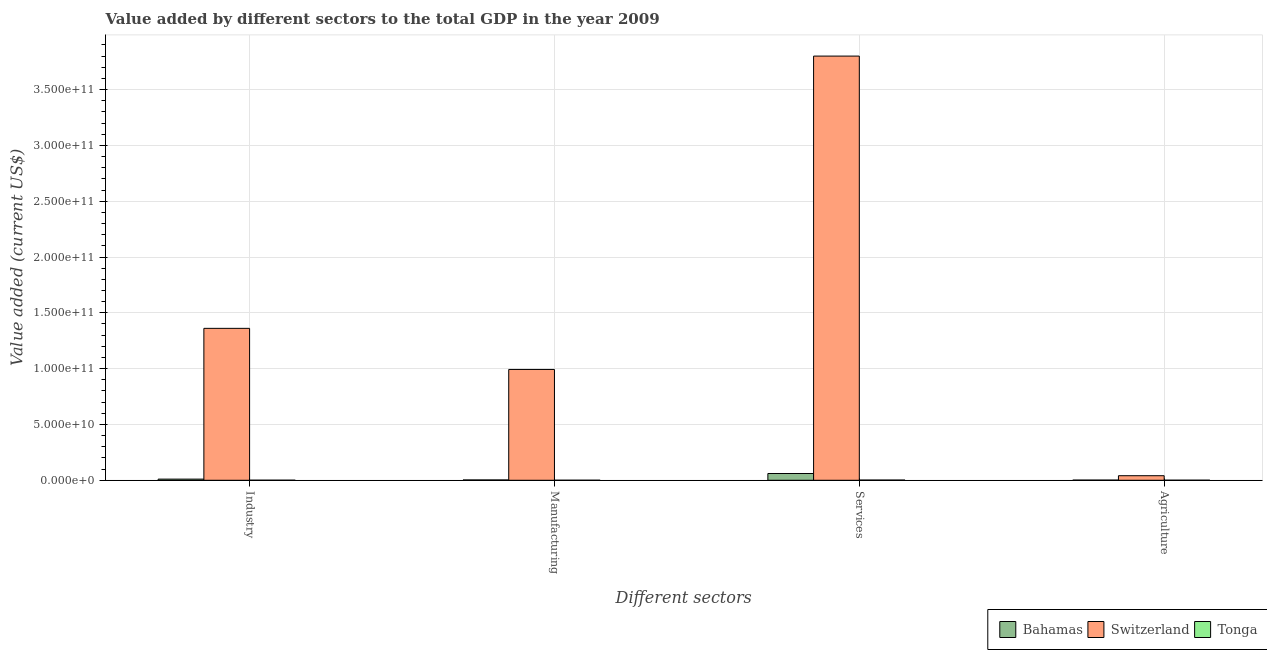How many different coloured bars are there?
Your answer should be very brief. 3. How many groups of bars are there?
Your answer should be compact. 4. Are the number of bars on each tick of the X-axis equal?
Your response must be concise. Yes. How many bars are there on the 3rd tick from the left?
Make the answer very short. 3. What is the label of the 4th group of bars from the left?
Offer a terse response. Agriculture. What is the value added by manufacturing sector in Bahamas?
Provide a succinct answer. 2.88e+08. Across all countries, what is the maximum value added by agricultural sector?
Your response must be concise. 4.08e+09. Across all countries, what is the minimum value added by manufacturing sector?
Your response must be concise. 2.13e+07. In which country was the value added by industrial sector maximum?
Ensure brevity in your answer.  Switzerland. In which country was the value added by agricultural sector minimum?
Your response must be concise. Tonga. What is the total value added by manufacturing sector in the graph?
Your answer should be very brief. 9.96e+1. What is the difference between the value added by agricultural sector in Tonga and that in Bahamas?
Your answer should be very brief. -9.88e+07. What is the difference between the value added by industrial sector in Switzerland and the value added by agricultural sector in Tonga?
Provide a succinct answer. 1.36e+11. What is the average value added by manufacturing sector per country?
Make the answer very short. 3.32e+1. What is the difference between the value added by manufacturing sector and value added by services sector in Switzerland?
Provide a short and direct response. -2.81e+11. In how many countries, is the value added by manufacturing sector greater than 350000000000 US$?
Your answer should be very brief. 0. What is the ratio of the value added by industrial sector in Bahamas to that in Tonga?
Offer a terse response. 19.07. Is the value added by industrial sector in Bahamas less than that in Tonga?
Provide a succinct answer. No. What is the difference between the highest and the second highest value added by agricultural sector?
Keep it short and to the point. 3.93e+09. What is the difference between the highest and the lowest value added by services sector?
Your answer should be very brief. 3.80e+11. Is the sum of the value added by agricultural sector in Bahamas and Tonga greater than the maximum value added by industrial sector across all countries?
Ensure brevity in your answer.  No. Is it the case that in every country, the sum of the value added by agricultural sector and value added by services sector is greater than the sum of value added by industrial sector and value added by manufacturing sector?
Give a very brief answer. No. What does the 1st bar from the left in Agriculture represents?
Ensure brevity in your answer.  Bahamas. What does the 3rd bar from the right in Industry represents?
Offer a terse response. Bahamas. Is it the case that in every country, the sum of the value added by industrial sector and value added by manufacturing sector is greater than the value added by services sector?
Ensure brevity in your answer.  No. How many countries are there in the graph?
Keep it short and to the point. 3. Are the values on the major ticks of Y-axis written in scientific E-notation?
Provide a succinct answer. Yes. Does the graph contain any zero values?
Your answer should be very brief. No. Where does the legend appear in the graph?
Your answer should be very brief. Bottom right. How many legend labels are there?
Provide a succinct answer. 3. How are the legend labels stacked?
Offer a terse response. Horizontal. What is the title of the graph?
Offer a terse response. Value added by different sectors to the total GDP in the year 2009. What is the label or title of the X-axis?
Ensure brevity in your answer.  Different sectors. What is the label or title of the Y-axis?
Your response must be concise. Value added (current US$). What is the Value added (current US$) of Bahamas in Industry?
Your response must be concise. 1.03e+09. What is the Value added (current US$) of Switzerland in Industry?
Keep it short and to the point. 1.36e+11. What is the Value added (current US$) in Tonga in Industry?
Your answer should be very brief. 5.43e+07. What is the Value added (current US$) in Bahamas in Manufacturing?
Your response must be concise. 2.88e+08. What is the Value added (current US$) in Switzerland in Manufacturing?
Offer a terse response. 9.93e+1. What is the Value added (current US$) of Tonga in Manufacturing?
Provide a succinct answer. 2.13e+07. What is the Value added (current US$) in Bahamas in Services?
Offer a terse response. 6.06e+09. What is the Value added (current US$) in Switzerland in Services?
Keep it short and to the point. 3.80e+11. What is the Value added (current US$) of Tonga in Services?
Your response must be concise. 1.75e+08. What is the Value added (current US$) of Bahamas in Agriculture?
Offer a terse response. 1.49e+08. What is the Value added (current US$) in Switzerland in Agriculture?
Give a very brief answer. 4.08e+09. What is the Value added (current US$) in Tonga in Agriculture?
Offer a terse response. 5.00e+07. Across all Different sectors, what is the maximum Value added (current US$) of Bahamas?
Provide a succinct answer. 6.06e+09. Across all Different sectors, what is the maximum Value added (current US$) in Switzerland?
Provide a short and direct response. 3.80e+11. Across all Different sectors, what is the maximum Value added (current US$) of Tonga?
Your answer should be very brief. 1.75e+08. Across all Different sectors, what is the minimum Value added (current US$) in Bahamas?
Make the answer very short. 1.49e+08. Across all Different sectors, what is the minimum Value added (current US$) of Switzerland?
Ensure brevity in your answer.  4.08e+09. Across all Different sectors, what is the minimum Value added (current US$) in Tonga?
Provide a succinct answer. 2.13e+07. What is the total Value added (current US$) of Bahamas in the graph?
Keep it short and to the point. 7.53e+09. What is the total Value added (current US$) of Switzerland in the graph?
Your response must be concise. 6.19e+11. What is the total Value added (current US$) in Tonga in the graph?
Provide a succinct answer. 3.01e+08. What is the difference between the Value added (current US$) of Bahamas in Industry and that in Manufacturing?
Offer a very short reply. 7.46e+08. What is the difference between the Value added (current US$) of Switzerland in Industry and that in Manufacturing?
Make the answer very short. 3.68e+1. What is the difference between the Value added (current US$) in Tonga in Industry and that in Manufacturing?
Offer a terse response. 3.30e+07. What is the difference between the Value added (current US$) in Bahamas in Industry and that in Services?
Provide a short and direct response. -5.03e+09. What is the difference between the Value added (current US$) of Switzerland in Industry and that in Services?
Provide a succinct answer. -2.44e+11. What is the difference between the Value added (current US$) in Tonga in Industry and that in Services?
Offer a very short reply. -1.21e+08. What is the difference between the Value added (current US$) in Bahamas in Industry and that in Agriculture?
Give a very brief answer. 8.86e+08. What is the difference between the Value added (current US$) of Switzerland in Industry and that in Agriculture?
Keep it short and to the point. 1.32e+11. What is the difference between the Value added (current US$) of Tonga in Industry and that in Agriculture?
Offer a terse response. 4.23e+06. What is the difference between the Value added (current US$) in Bahamas in Manufacturing and that in Services?
Offer a very short reply. -5.77e+09. What is the difference between the Value added (current US$) in Switzerland in Manufacturing and that in Services?
Make the answer very short. -2.81e+11. What is the difference between the Value added (current US$) of Tonga in Manufacturing and that in Services?
Your answer should be very brief. -1.54e+08. What is the difference between the Value added (current US$) in Bahamas in Manufacturing and that in Agriculture?
Your answer should be compact. 1.39e+08. What is the difference between the Value added (current US$) of Switzerland in Manufacturing and that in Agriculture?
Give a very brief answer. 9.52e+1. What is the difference between the Value added (current US$) in Tonga in Manufacturing and that in Agriculture?
Offer a very short reply. -2.87e+07. What is the difference between the Value added (current US$) of Bahamas in Services and that in Agriculture?
Make the answer very short. 5.91e+09. What is the difference between the Value added (current US$) of Switzerland in Services and that in Agriculture?
Offer a terse response. 3.76e+11. What is the difference between the Value added (current US$) in Tonga in Services and that in Agriculture?
Make the answer very short. 1.25e+08. What is the difference between the Value added (current US$) of Bahamas in Industry and the Value added (current US$) of Switzerland in Manufacturing?
Your answer should be very brief. -9.82e+1. What is the difference between the Value added (current US$) of Bahamas in Industry and the Value added (current US$) of Tonga in Manufacturing?
Make the answer very short. 1.01e+09. What is the difference between the Value added (current US$) of Switzerland in Industry and the Value added (current US$) of Tonga in Manufacturing?
Give a very brief answer. 1.36e+11. What is the difference between the Value added (current US$) of Bahamas in Industry and the Value added (current US$) of Switzerland in Services?
Your answer should be compact. -3.79e+11. What is the difference between the Value added (current US$) in Bahamas in Industry and the Value added (current US$) in Tonga in Services?
Provide a succinct answer. 8.59e+08. What is the difference between the Value added (current US$) in Switzerland in Industry and the Value added (current US$) in Tonga in Services?
Give a very brief answer. 1.36e+11. What is the difference between the Value added (current US$) in Bahamas in Industry and the Value added (current US$) in Switzerland in Agriculture?
Your answer should be very brief. -3.05e+09. What is the difference between the Value added (current US$) in Bahamas in Industry and the Value added (current US$) in Tonga in Agriculture?
Give a very brief answer. 9.84e+08. What is the difference between the Value added (current US$) of Switzerland in Industry and the Value added (current US$) of Tonga in Agriculture?
Your answer should be very brief. 1.36e+11. What is the difference between the Value added (current US$) in Bahamas in Manufacturing and the Value added (current US$) in Switzerland in Services?
Provide a succinct answer. -3.80e+11. What is the difference between the Value added (current US$) of Bahamas in Manufacturing and the Value added (current US$) of Tonga in Services?
Your answer should be compact. 1.13e+08. What is the difference between the Value added (current US$) in Switzerland in Manufacturing and the Value added (current US$) in Tonga in Services?
Provide a succinct answer. 9.91e+1. What is the difference between the Value added (current US$) of Bahamas in Manufacturing and the Value added (current US$) of Switzerland in Agriculture?
Offer a terse response. -3.79e+09. What is the difference between the Value added (current US$) of Bahamas in Manufacturing and the Value added (current US$) of Tonga in Agriculture?
Your answer should be compact. 2.38e+08. What is the difference between the Value added (current US$) of Switzerland in Manufacturing and the Value added (current US$) of Tonga in Agriculture?
Provide a succinct answer. 9.92e+1. What is the difference between the Value added (current US$) of Bahamas in Services and the Value added (current US$) of Switzerland in Agriculture?
Your response must be concise. 1.98e+09. What is the difference between the Value added (current US$) of Bahamas in Services and the Value added (current US$) of Tonga in Agriculture?
Provide a succinct answer. 6.01e+09. What is the difference between the Value added (current US$) in Switzerland in Services and the Value added (current US$) in Tonga in Agriculture?
Your answer should be compact. 3.80e+11. What is the average Value added (current US$) in Bahamas per Different sectors?
Your response must be concise. 1.88e+09. What is the average Value added (current US$) of Switzerland per Different sectors?
Offer a very short reply. 1.55e+11. What is the average Value added (current US$) of Tonga per Different sectors?
Your response must be concise. 7.52e+07. What is the difference between the Value added (current US$) of Bahamas and Value added (current US$) of Switzerland in Industry?
Give a very brief answer. -1.35e+11. What is the difference between the Value added (current US$) of Bahamas and Value added (current US$) of Tonga in Industry?
Offer a terse response. 9.80e+08. What is the difference between the Value added (current US$) in Switzerland and Value added (current US$) in Tonga in Industry?
Provide a succinct answer. 1.36e+11. What is the difference between the Value added (current US$) in Bahamas and Value added (current US$) in Switzerland in Manufacturing?
Provide a short and direct response. -9.90e+1. What is the difference between the Value added (current US$) of Bahamas and Value added (current US$) of Tonga in Manufacturing?
Ensure brevity in your answer.  2.67e+08. What is the difference between the Value added (current US$) in Switzerland and Value added (current US$) in Tonga in Manufacturing?
Your answer should be compact. 9.92e+1. What is the difference between the Value added (current US$) of Bahamas and Value added (current US$) of Switzerland in Services?
Your answer should be very brief. -3.74e+11. What is the difference between the Value added (current US$) of Bahamas and Value added (current US$) of Tonga in Services?
Provide a short and direct response. 5.89e+09. What is the difference between the Value added (current US$) of Switzerland and Value added (current US$) of Tonga in Services?
Offer a very short reply. 3.80e+11. What is the difference between the Value added (current US$) of Bahamas and Value added (current US$) of Switzerland in Agriculture?
Give a very brief answer. -3.93e+09. What is the difference between the Value added (current US$) in Bahamas and Value added (current US$) in Tonga in Agriculture?
Provide a short and direct response. 9.88e+07. What is the difference between the Value added (current US$) of Switzerland and Value added (current US$) of Tonga in Agriculture?
Make the answer very short. 4.03e+09. What is the ratio of the Value added (current US$) of Bahamas in Industry to that in Manufacturing?
Offer a terse response. 3.59. What is the ratio of the Value added (current US$) in Switzerland in Industry to that in Manufacturing?
Provide a short and direct response. 1.37. What is the ratio of the Value added (current US$) of Tonga in Industry to that in Manufacturing?
Keep it short and to the point. 2.55. What is the ratio of the Value added (current US$) in Bahamas in Industry to that in Services?
Make the answer very short. 0.17. What is the ratio of the Value added (current US$) in Switzerland in Industry to that in Services?
Your response must be concise. 0.36. What is the ratio of the Value added (current US$) in Tonga in Industry to that in Services?
Your answer should be compact. 0.31. What is the ratio of the Value added (current US$) in Bahamas in Industry to that in Agriculture?
Your answer should be very brief. 6.95. What is the ratio of the Value added (current US$) in Switzerland in Industry to that in Agriculture?
Offer a very short reply. 33.35. What is the ratio of the Value added (current US$) of Tonga in Industry to that in Agriculture?
Offer a very short reply. 1.08. What is the ratio of the Value added (current US$) in Bahamas in Manufacturing to that in Services?
Ensure brevity in your answer.  0.05. What is the ratio of the Value added (current US$) in Switzerland in Manufacturing to that in Services?
Ensure brevity in your answer.  0.26. What is the ratio of the Value added (current US$) of Tonga in Manufacturing to that in Services?
Keep it short and to the point. 0.12. What is the ratio of the Value added (current US$) in Bahamas in Manufacturing to that in Agriculture?
Make the answer very short. 1.94. What is the ratio of the Value added (current US$) of Switzerland in Manufacturing to that in Agriculture?
Give a very brief answer. 24.32. What is the ratio of the Value added (current US$) of Tonga in Manufacturing to that in Agriculture?
Your answer should be compact. 0.43. What is the ratio of the Value added (current US$) in Bahamas in Services to that in Agriculture?
Provide a succinct answer. 40.71. What is the ratio of the Value added (current US$) of Switzerland in Services to that in Agriculture?
Your answer should be very brief. 93.12. What is the ratio of the Value added (current US$) of Tonga in Services to that in Agriculture?
Your answer should be very brief. 3.5. What is the difference between the highest and the second highest Value added (current US$) of Bahamas?
Your answer should be compact. 5.03e+09. What is the difference between the highest and the second highest Value added (current US$) of Switzerland?
Provide a short and direct response. 2.44e+11. What is the difference between the highest and the second highest Value added (current US$) of Tonga?
Your answer should be very brief. 1.21e+08. What is the difference between the highest and the lowest Value added (current US$) of Bahamas?
Make the answer very short. 5.91e+09. What is the difference between the highest and the lowest Value added (current US$) of Switzerland?
Keep it short and to the point. 3.76e+11. What is the difference between the highest and the lowest Value added (current US$) in Tonga?
Make the answer very short. 1.54e+08. 